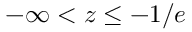Convert formula to latex. <formula><loc_0><loc_0><loc_500><loc_500>- \infty < z \leq - 1 / e</formula> 